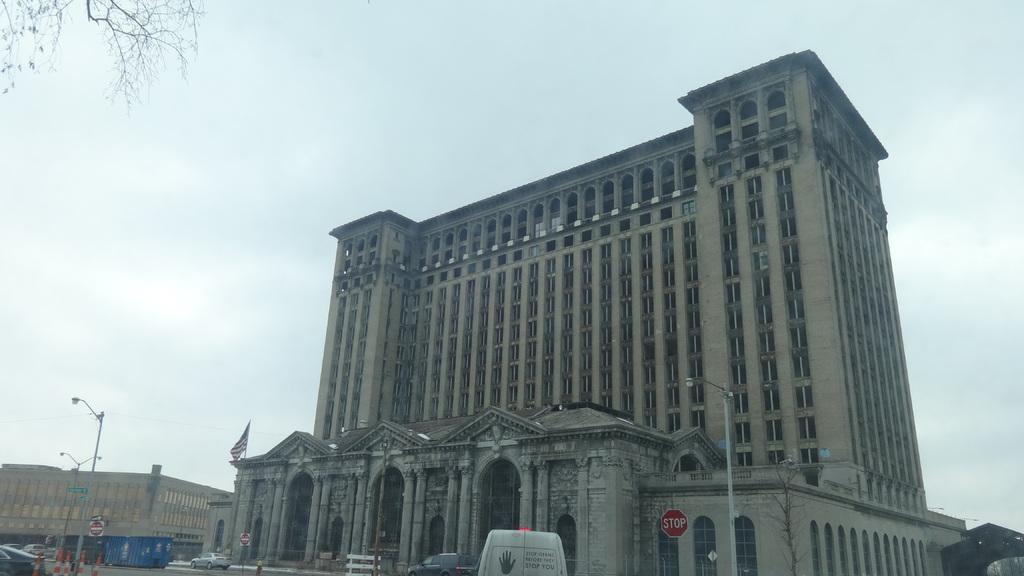In one or two sentences, can you explain what this image depicts? In this image I can see few buildings, few poles, street lights, a flag, few sign boards, few trees and I can also see number of vehicles on road. Over there I can see few traffic cones and in background I can see the sky. 